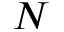Convert formula to latex. <formula><loc_0><loc_0><loc_500><loc_500>N</formula> 